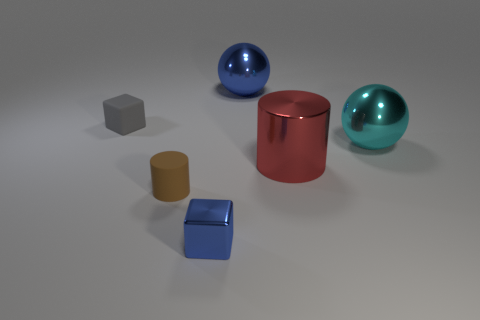Add 1 small gray matte balls. How many objects exist? 7 Subtract all cubes. How many objects are left? 4 Add 5 large red things. How many large red things are left? 6 Add 5 big purple cubes. How many big purple cubes exist? 5 Subtract 0 red balls. How many objects are left? 6 Subtract all big blue shiny objects. Subtract all shiny cubes. How many objects are left? 4 